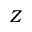<formula> <loc_0><loc_0><loc_500><loc_500>Z</formula> 